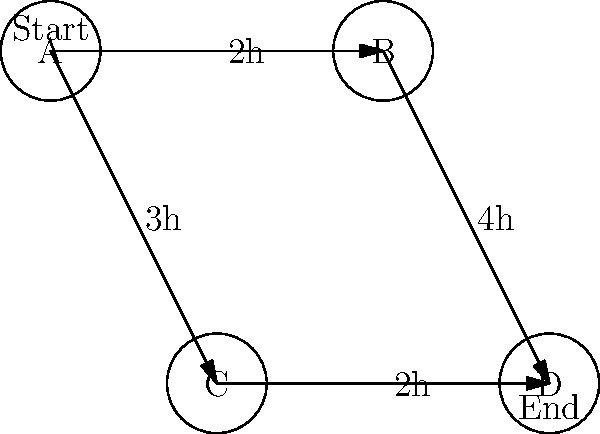You have four customers (A, B, C, and D) who need their cars repaired. The diagram shows the repair dependencies and times. Each node represents a customer's car, and each edge represents the time needed to complete the repair before moving to the next car. What is the shortest time (in hours) to complete all repairs, assuming you can only work on one car at a time? To find the shortest time to complete all repairs, we need to identify the critical path in the graph. Let's analyze the possible paths:

1. Path A → B → D:
   Time = 2h (A to B) + 4h (B to D) = 6h

2. Path A → C → D:
   Time = 3h (A to C) + 2h (C to D) = 5h

The critical path is the one with the longest total time, as it determines the minimum time required to complete all repairs. In this case, the critical path is A → B → D, which takes 6 hours.

It's important to note that even though the A → C → D path is shorter, we cannot complete the repairs any faster because we must wait for the B → D repair to finish.

Therefore, the shortest time to complete all repairs is 6 hours.
Answer: 6 hours 